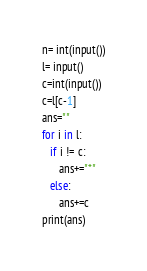Convert code to text. <code><loc_0><loc_0><loc_500><loc_500><_Python_>n= int(input())
l= input()
c=int(input())
c=l[c-1]
ans=""
for i in l:
   if i != c:
      ans+="*"
   else:
      ans+=c
print(ans)</code> 